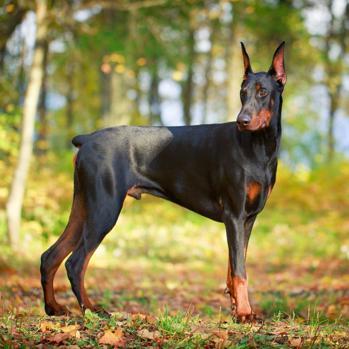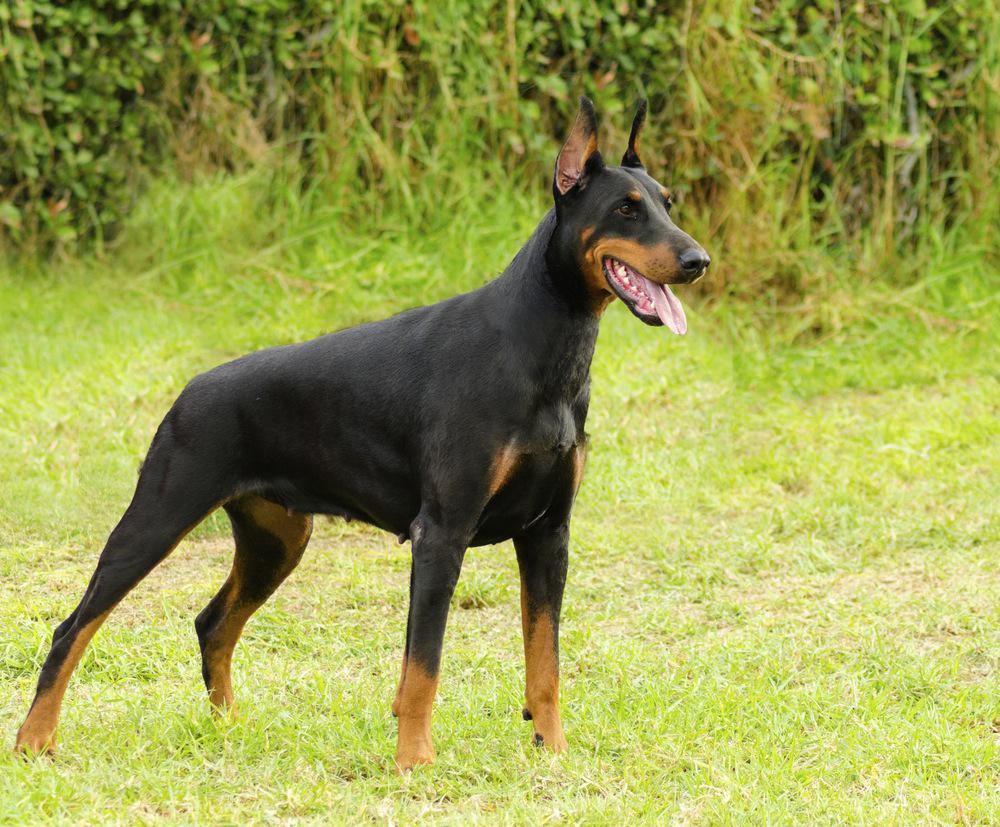The first image is the image on the left, the second image is the image on the right. Evaluate the accuracy of this statement regarding the images: "One image shows one pointy-eared doberman in a collar reclining on green ground, and the other image shows one leftward-facing doberman with a closed mouth and pointy ears.". Is it true? Answer yes or no. No. The first image is the image on the left, the second image is the image on the right. Analyze the images presented: Is the assertion "One dog is reclining." valid? Answer yes or no. No. 